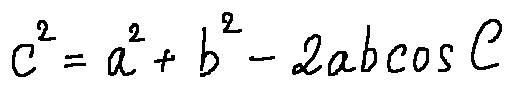Convert formula to latex. <formula><loc_0><loc_0><loc_500><loc_500>c ^ { 2 } = a ^ { 2 } + b ^ { 2 } - 2 a b \cos C</formula> 